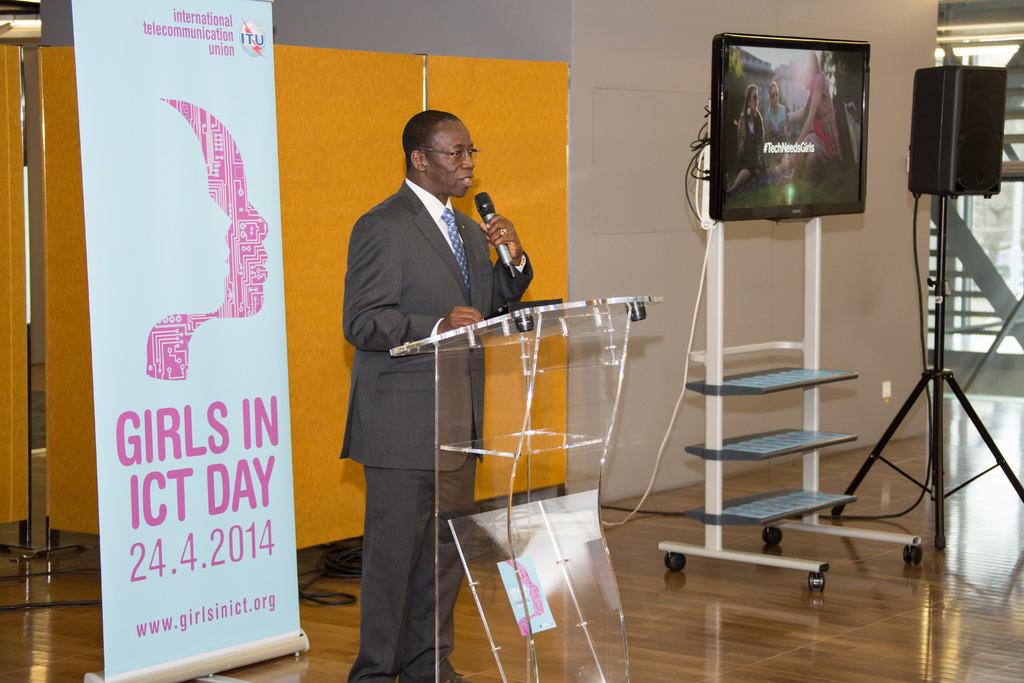<image>
Render a clear and concise summary of the photo. A man stands in front of a podium on Girls In ICT day. 